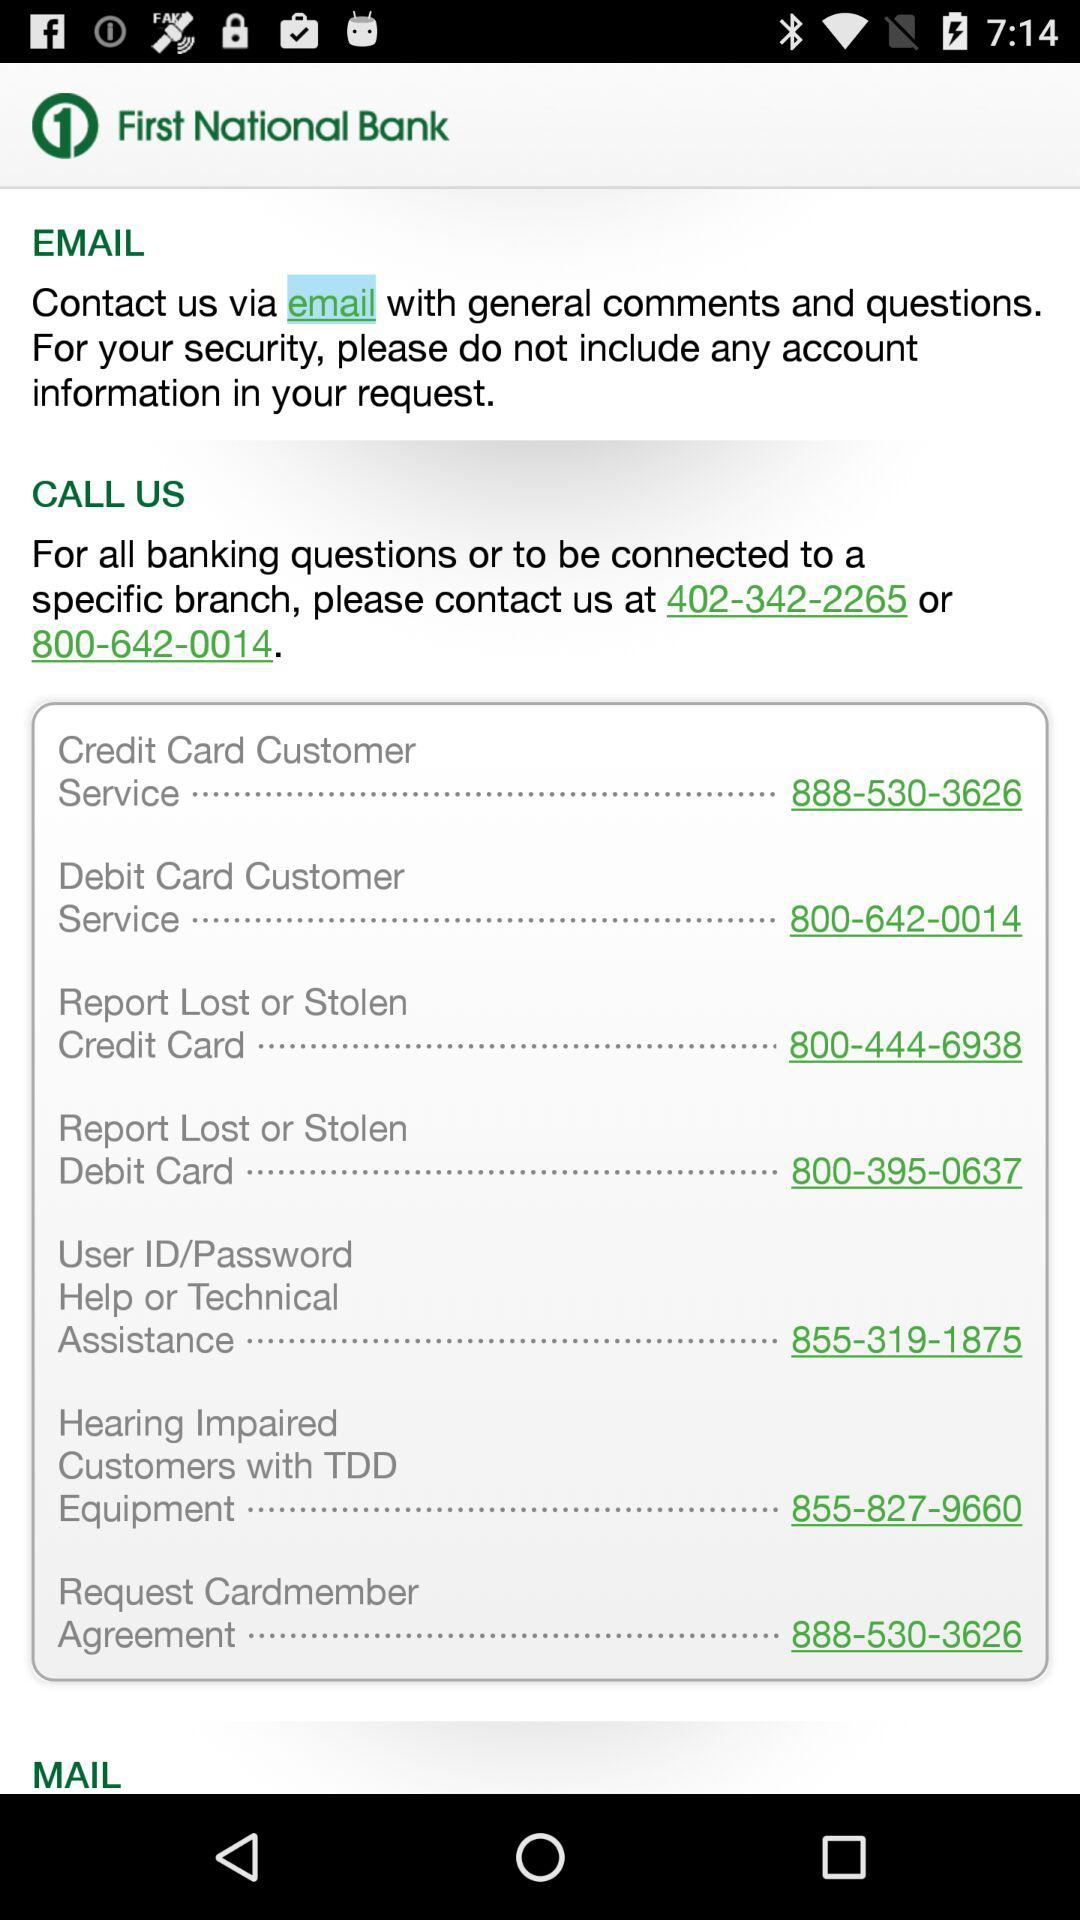What is the contact number of the credit card customer service? The contact number of the credit card customer service is 888-530-3626. 